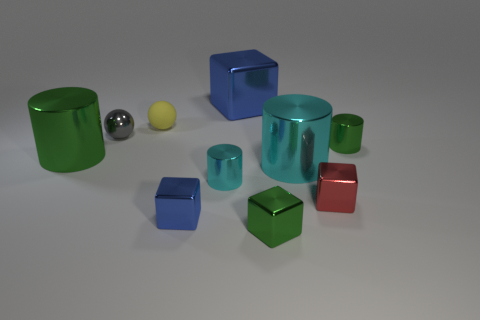Subtract all big blocks. How many blocks are left? 3 Subtract 2 cylinders. How many cylinders are left? 2 Subtract all yellow balls. How many balls are left? 1 Subtract all purple blocks. Subtract all gray spheres. How many blocks are left? 4 Subtract all cyan cylinders. How many purple blocks are left? 0 Subtract all green things. Subtract all green blocks. How many objects are left? 6 Add 6 rubber objects. How many rubber objects are left? 7 Add 5 small red cubes. How many small red cubes exist? 6 Subtract 0 purple cylinders. How many objects are left? 10 Subtract all cubes. How many objects are left? 6 